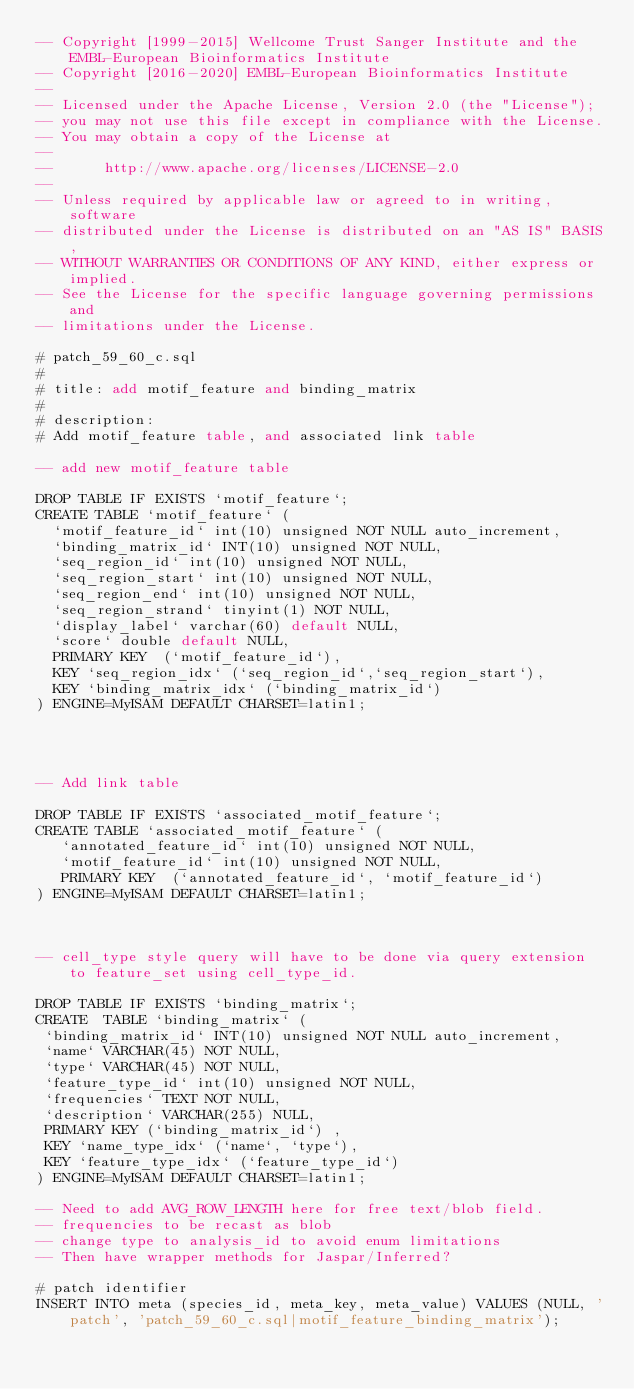Convert code to text. <code><loc_0><loc_0><loc_500><loc_500><_SQL_>-- Copyright [1999-2015] Wellcome Trust Sanger Institute and the EMBL-European Bioinformatics Institute
-- Copyright [2016-2020] EMBL-European Bioinformatics Institute
-- 
-- Licensed under the Apache License, Version 2.0 (the "License");
-- you may not use this file except in compliance with the License.
-- You may obtain a copy of the License at
-- 
--      http://www.apache.org/licenses/LICENSE-2.0
-- 
-- Unless required by applicable law or agreed to in writing, software
-- distributed under the License is distributed on an "AS IS" BASIS,
-- WITHOUT WARRANTIES OR CONDITIONS OF ANY KIND, either express or implied.
-- See the License for the specific language governing permissions and
-- limitations under the License.

# patch_59_60_c.sql
#
# title: add motif_feature and binding_matrix
#
# description:
# Add motif_feature table, and associated link table

-- add new motif_feature table

DROP TABLE IF EXISTS `motif_feature`;
CREATE TABLE `motif_feature` (
  `motif_feature_id` int(10) unsigned NOT NULL auto_increment,
  `binding_matrix_id` INT(10) unsigned NOT NULL,
  `seq_region_id` int(10) unsigned NOT NULL,
  `seq_region_start` int(10) unsigned NOT NULL,
  `seq_region_end` int(10) unsigned NOT NULL,
  `seq_region_strand` tinyint(1) NOT NULL,
  `display_label` varchar(60) default NULL,
  `score` double default NULL,
  PRIMARY KEY  (`motif_feature_id`),
  KEY `seq_region_idx` (`seq_region_id`,`seq_region_start`),
  KEY `binding_matrix_idx` (`binding_matrix_id`)
) ENGINE=MyISAM DEFAULT CHARSET=latin1;




-- Add link table

DROP TABLE IF EXISTS `associated_motif_feature`;
CREATE TABLE `associated_motif_feature` (
   `annotated_feature_id` int(10) unsigned NOT NULL,
   `motif_feature_id` int(10) unsigned NOT NULL,
   PRIMARY KEY  (`annotated_feature_id`, `motif_feature_id`)
) ENGINE=MyISAM DEFAULT CHARSET=latin1;



-- cell_type style query will have to be done via query extension to feature_set using cell_type_id.

DROP TABLE IF EXISTS `binding_matrix`;
CREATE  TABLE `binding_matrix` (
 `binding_matrix_id` INT(10) unsigned NOT NULL auto_increment,
 `name` VARCHAR(45) NOT NULL,
 `type` VARCHAR(45) NOT NULL,
 `feature_type_id` int(10) unsigned NOT NULL,
 `frequencies` TEXT NOT NULL,
 `description` VARCHAR(255) NULL,
 PRIMARY KEY (`binding_matrix_id`) ,
 KEY `name_type_idx` (`name`, `type`),
 KEY `feature_type_idx` (`feature_type_id`)
) ENGINE=MyISAM DEFAULT CHARSET=latin1;

-- Need to add AVG_ROW_LENGTH here for free text/blob field.
-- frequencies to be recast as blob
-- change type to analysis_id to avoid enum limitations
-- Then have wrapper methods for Jaspar/Inferred?

# patch identifier
INSERT INTO meta (species_id, meta_key, meta_value) VALUES (NULL, 'patch', 'patch_59_60_c.sql|motif_feature_binding_matrix');


</code> 